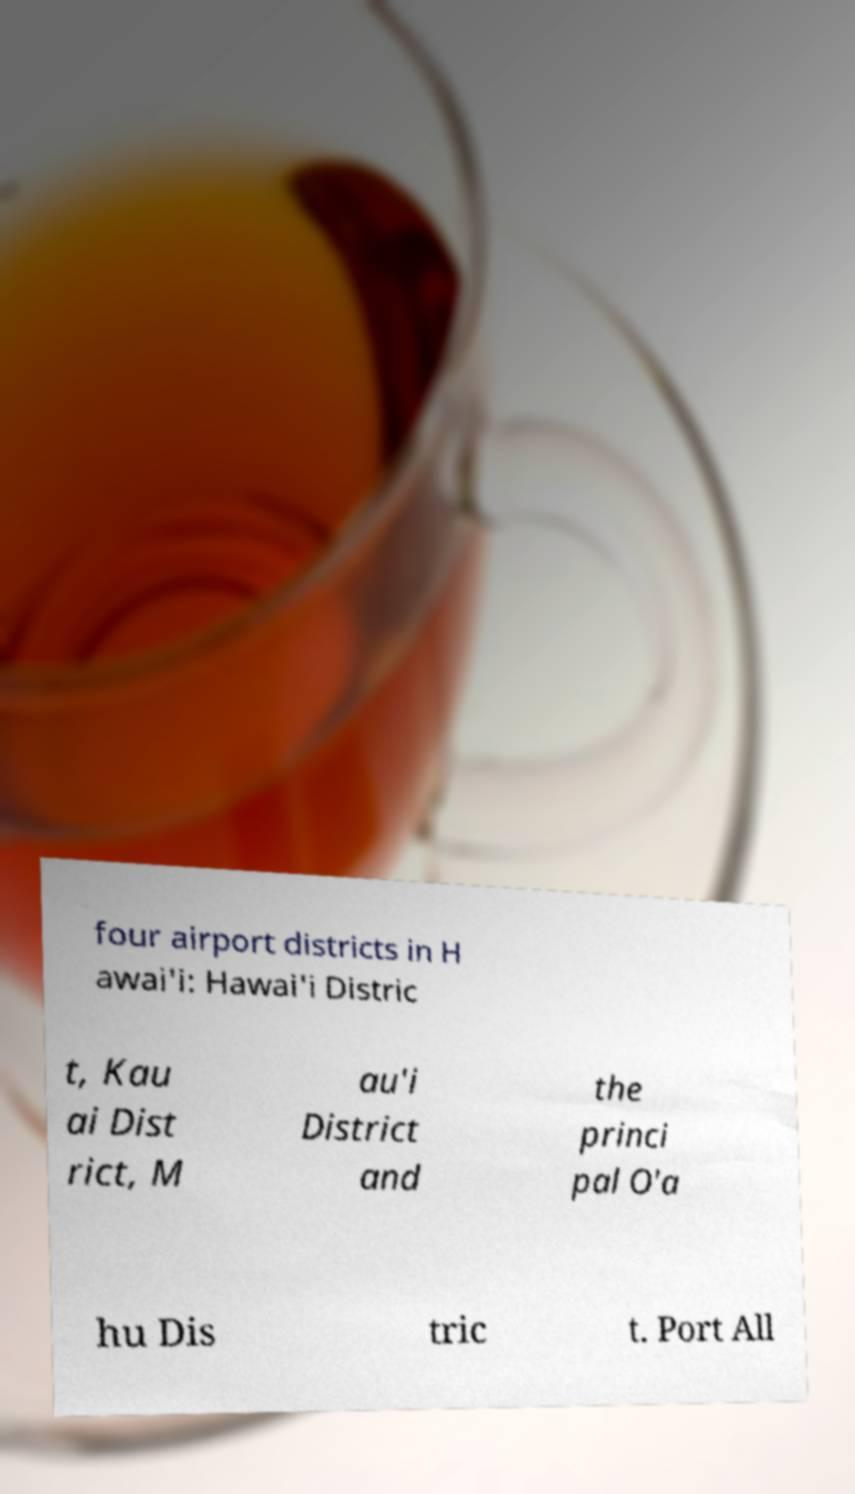Can you read and provide the text displayed in the image?This photo seems to have some interesting text. Can you extract and type it out for me? four airport districts in H awai'i: Hawai'i Distric t, Kau ai Dist rict, M au'i District and the princi pal O'a hu Dis tric t. Port All 